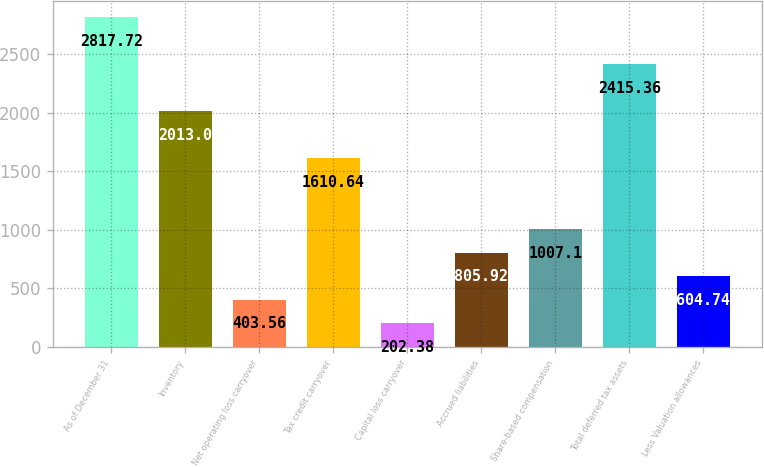<chart> <loc_0><loc_0><loc_500><loc_500><bar_chart><fcel>As of December 31<fcel>Inventory<fcel>Net operating loss carryover<fcel>Tax credit carryover<fcel>Capital loss carryover<fcel>Accrued liabilities<fcel>Share-based compensation<fcel>Total deferred tax assets<fcel>Less Valuation allowances<nl><fcel>2817.72<fcel>2013<fcel>403.56<fcel>1610.64<fcel>202.38<fcel>805.92<fcel>1007.1<fcel>2415.36<fcel>604.74<nl></chart> 